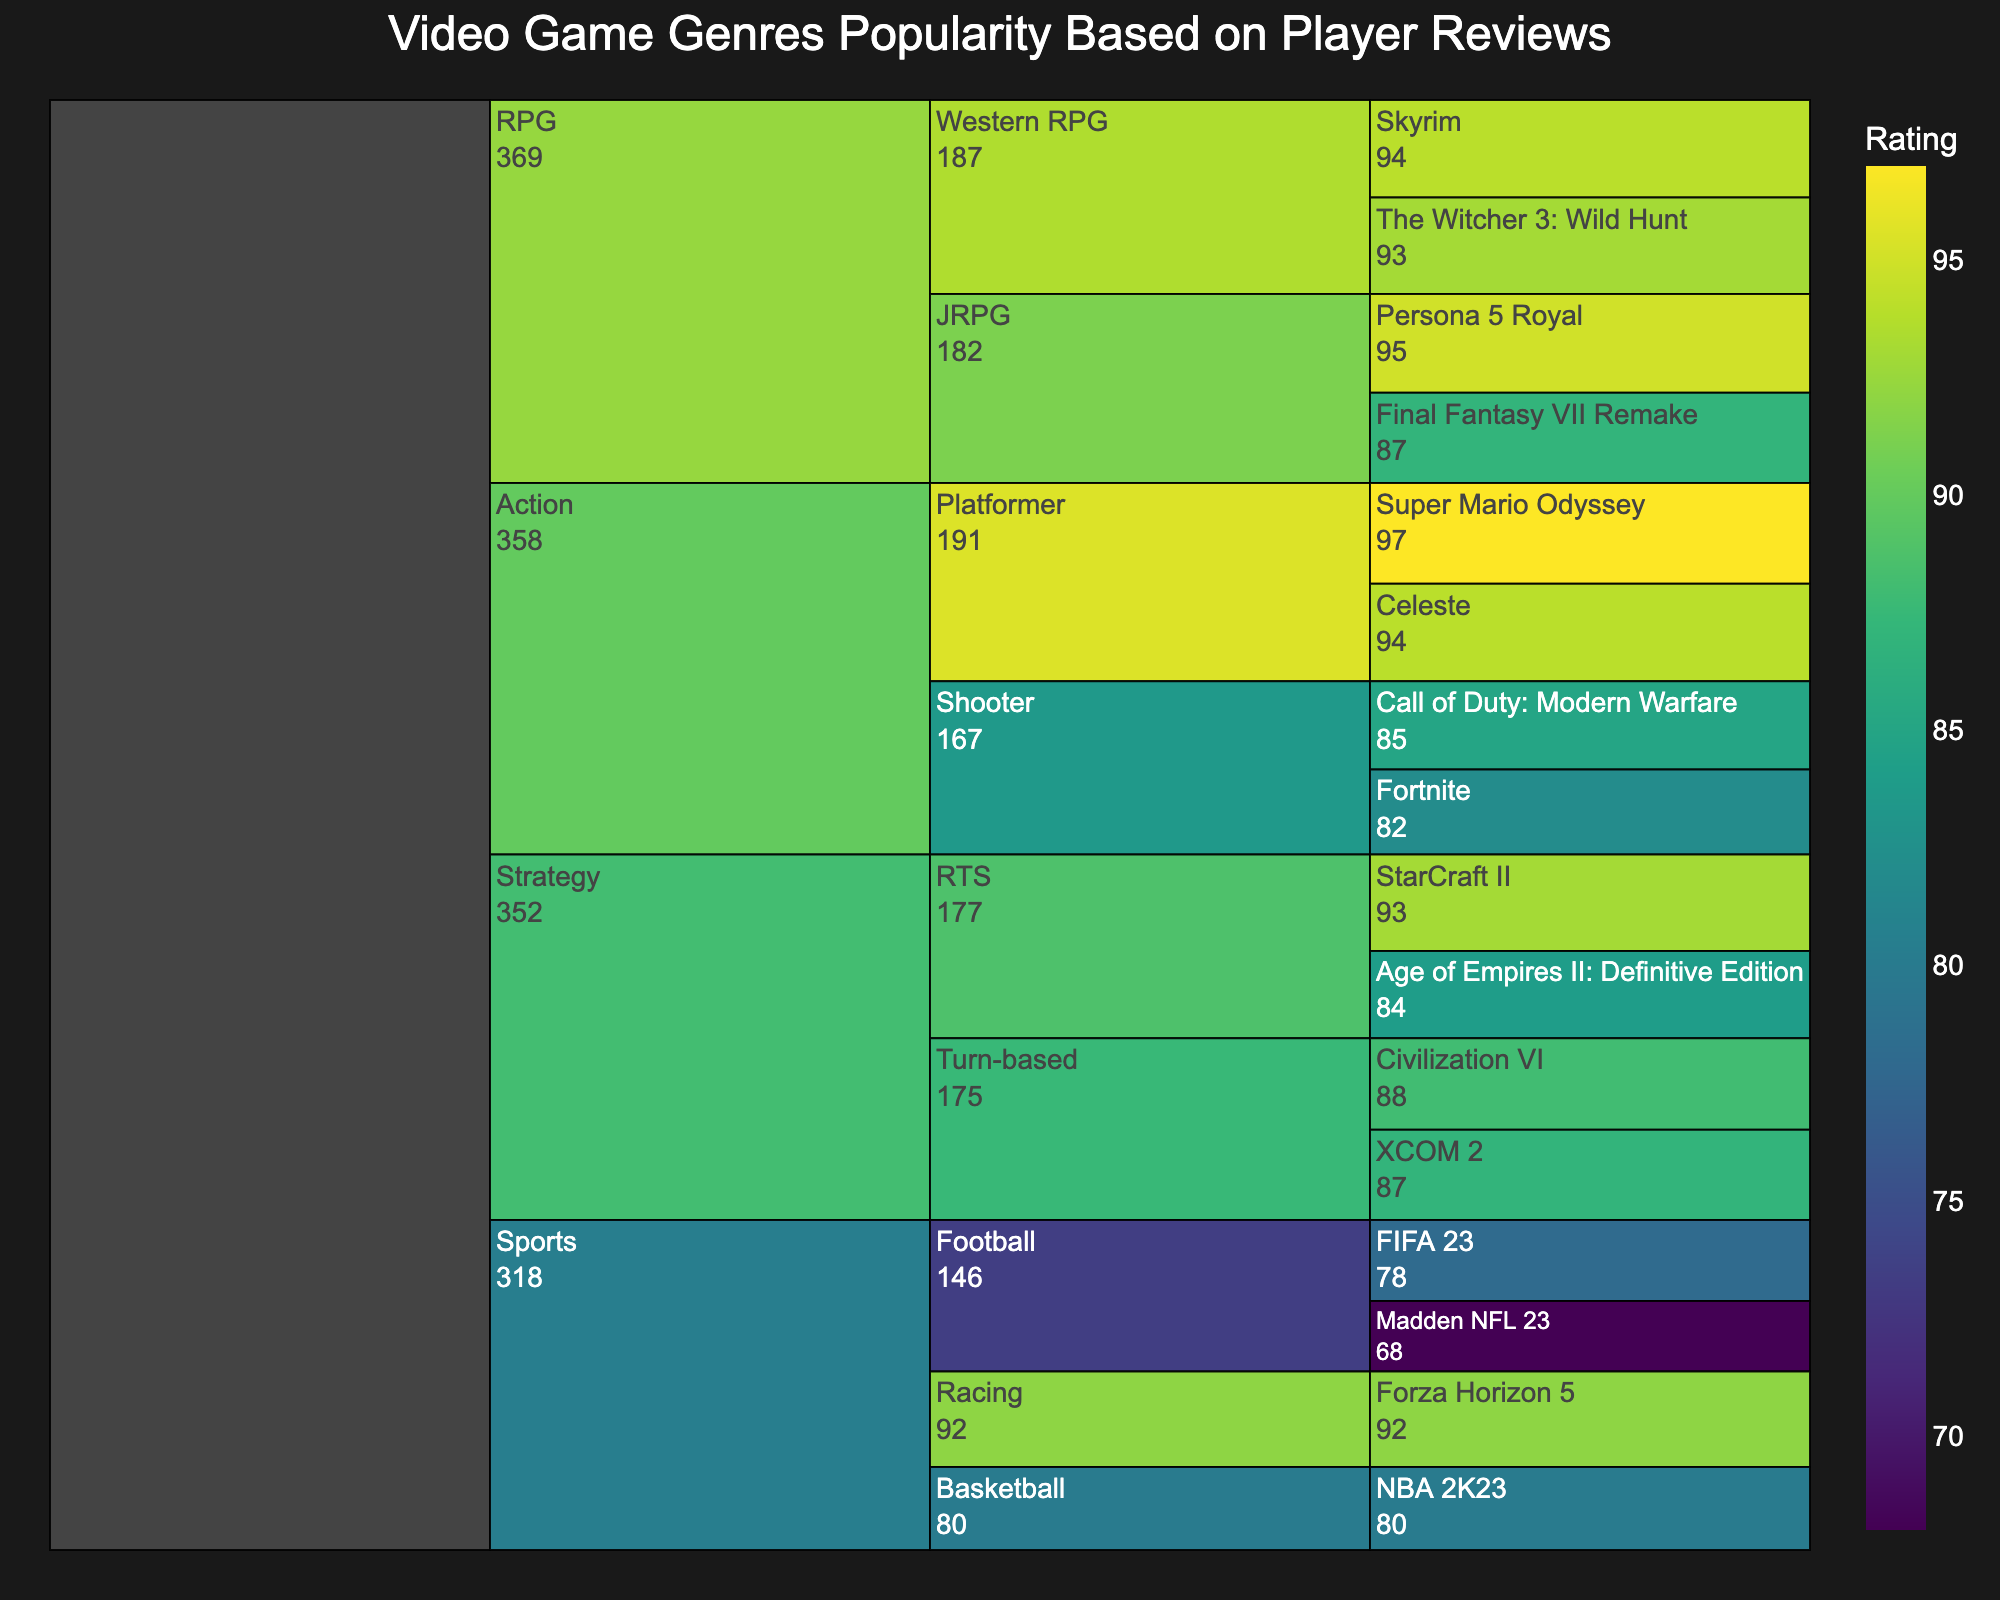What's the highest-rated video game in the Action genre? The highest-rated video game in the Action genre can be determined by looking at the ratings of the games under the Action genre section. Super Mario Odyssey has a rating of 97.
Answer: Super Mario Odyssey Which genre has the biggest range of ratings? To determine which genre has the biggest range of ratings, compare the difference between the highest and lowest ratings in each genre. The Sports genre ranges from 68 (Madden NFL 23) to 92 (Forza Horizon 5), a difference of 24 points.
Answer: Sports What's the average rating of games in the RPG genre? Calculate the average rating of the RPG games. Add up the ratings for Final Fantasy VII Remake (87), Persona 5 Royal (95), The Witcher 3: Wild Hunt (93), and Skyrim (94), then divide by the number of games (4). The sum is 369, so the average is 369/4.
Answer: 92.25 Which subgenre within Strategy has the higher rating overall? Compare the average ratings of the RTS and Turn-based subgenres within the Strategy genre. RTS includes StarCraft II (93) and Age of Empires II: DE (84), averaging (93+84)/2 = 88.5. Turn-based includes Civilization VI (88) and XCOM 2 (87), averaging (88+87)/2 = 87.5.
Answer: RTS What is the most popular subgenre in the Action genre? Determine the subgenre with the highest combined ratings within the Action genre. Shooter's total rating is 85 for Call of Duty: Modern Warfare + 82 for Fortnite = 167. Platformer's total rating is 97 for Super Mario Odyssey + 94 for Celeste = 191.
Answer: Platformer Which game has the lowest rating? Identify the game with the lowest rating by scanning the entire icicle chart. The lowest rating is for Madden NFL 23 with a rating of 68.
Answer: Madden NFL 23 What's the average rating of Strategy games? Calculate the average rating for Strategy games. Add the ratings for StarCraft II (93), Age of Empires II: DE (84), Civilization VI (88), and XCOM 2 (87), then divide by the number of games (4). The sum is 352, so the average is 352/4.
Answer: 88 Are there more games in the Action genre or the Sports genre? Compare the number of games listed under the Action and Sports genres on the chart. Action has 4 titles and Sports has 4 titles.
Answer: Equal Which genre has the highest-rated game overall? Examine the chart to find the highest rating and identify its genre. Super Mario Odyssey has the highest rating of 97, and it is in the Action genre.
Answer: Action Is the average rating higher in Turn-based or in Shooter subgenre? Compare the average ratings within the subgenres. Turn-based (Civilization VI and XCOM 2) has an average of (88+87)/2 = 87.5. Shooter (Call of Duty: Modern Warfare and Fortnite) has an average of (85+82)/2 = 83.5.
Answer: Turn-based 